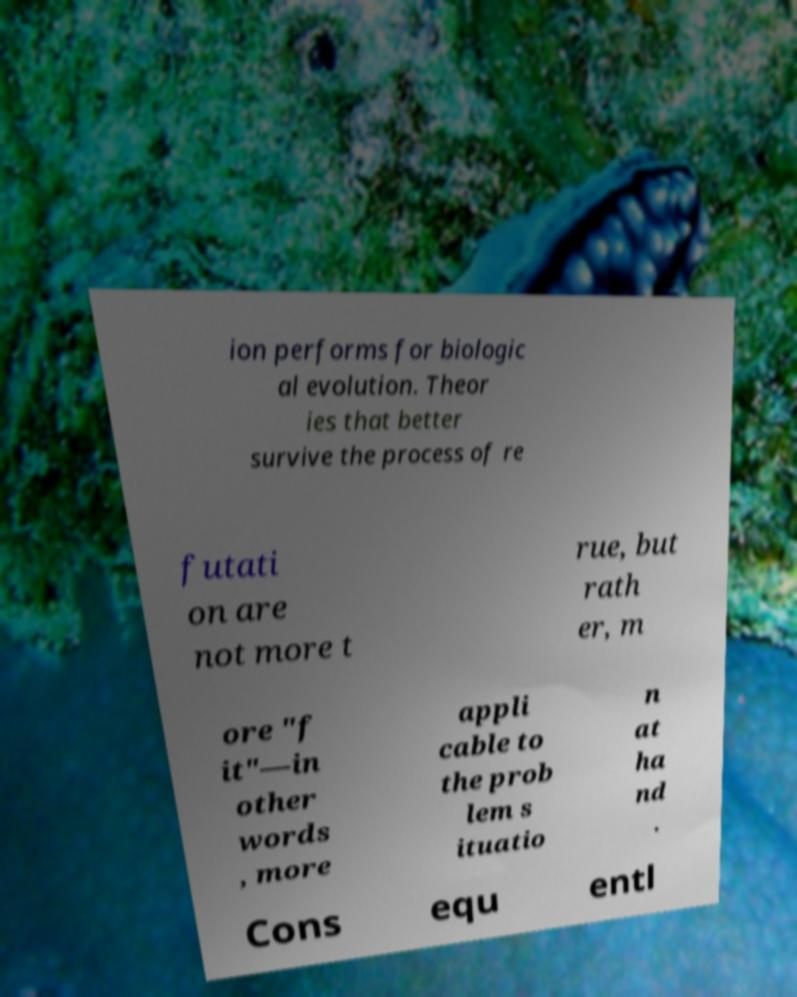Please identify and transcribe the text found in this image. ion performs for biologic al evolution. Theor ies that better survive the process of re futati on are not more t rue, but rath er, m ore "f it"—in other words , more appli cable to the prob lem s ituatio n at ha nd . Cons equ entl 